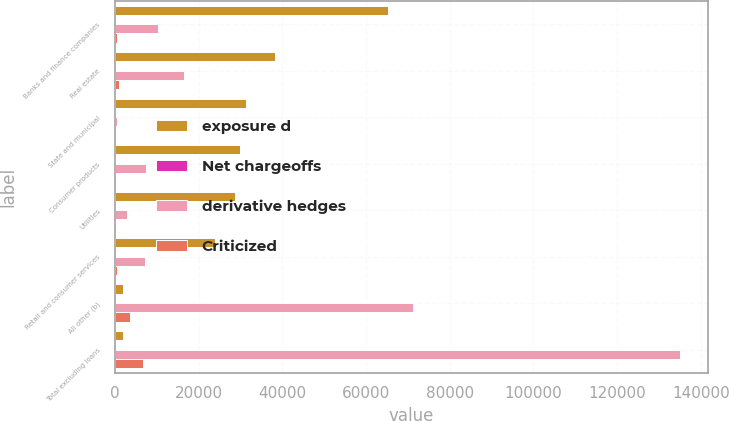Convert chart. <chart><loc_0><loc_0><loc_500><loc_500><stacked_bar_chart><ecel><fcel>Banks and finance companies<fcel>Real estate<fcel>State and municipal<fcel>Consumer products<fcel>Utilities<fcel>Retail and consumer services<fcel>All other (b)<fcel>Total excluding loans<nl><fcel>exposure d<fcel>65288<fcel>38295<fcel>31425<fcel>29941<fcel>28679<fcel>23969<fcel>2045.5<fcel>2045.5<nl><fcel>Net chargeoffs<fcel>83<fcel>54<fcel>98<fcel>74<fcel>89<fcel>68<fcel>80<fcel>80<nl><fcel>derivative hedges<fcel>10385<fcel>16626<fcel>591<fcel>7492<fcel>3021<fcel>7149<fcel>71211<fcel>134983<nl><fcel>Criticized<fcel>498<fcel>1070<fcel>12<fcel>239<fcel>212<fcel>550<fcel>3673<fcel>6838<nl></chart> 